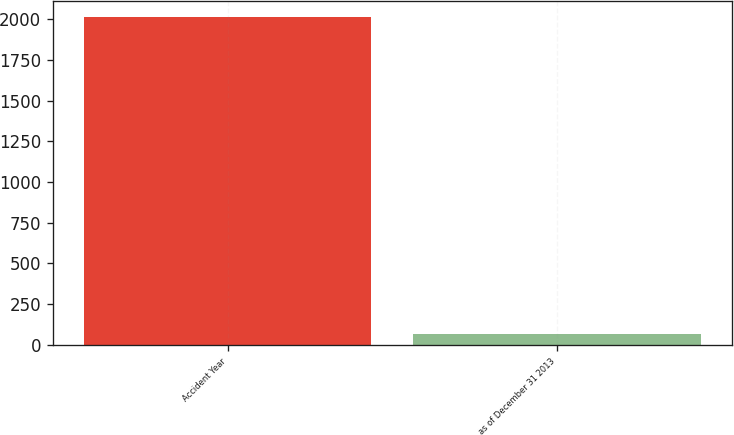Convert chart. <chart><loc_0><loc_0><loc_500><loc_500><bar_chart><fcel>Accident Year<fcel>as of December 31 2013<nl><fcel>2013<fcel>68.5<nl></chart> 